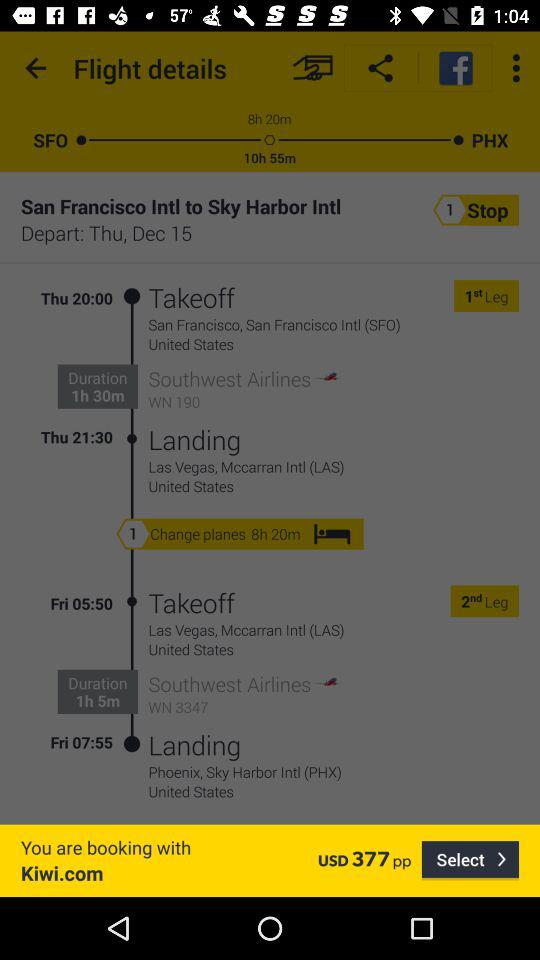How long is the total flight time?
Answer the question using a single word or phrase. 10h 55m 